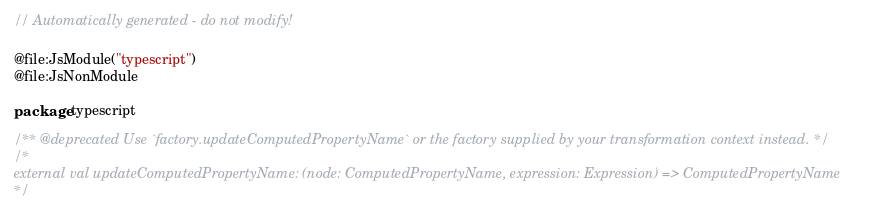Convert code to text. <code><loc_0><loc_0><loc_500><loc_500><_Kotlin_>// Automatically generated - do not modify!

@file:JsModule("typescript")
@file:JsNonModule

package typescript

/** @deprecated Use `factory.updateComputedPropertyName` or the factory supplied by your transformation context instead. */
/*
external val updateComputedPropertyName: (node: ComputedPropertyName, expression: Expression) => ComputedPropertyName
*/
</code> 